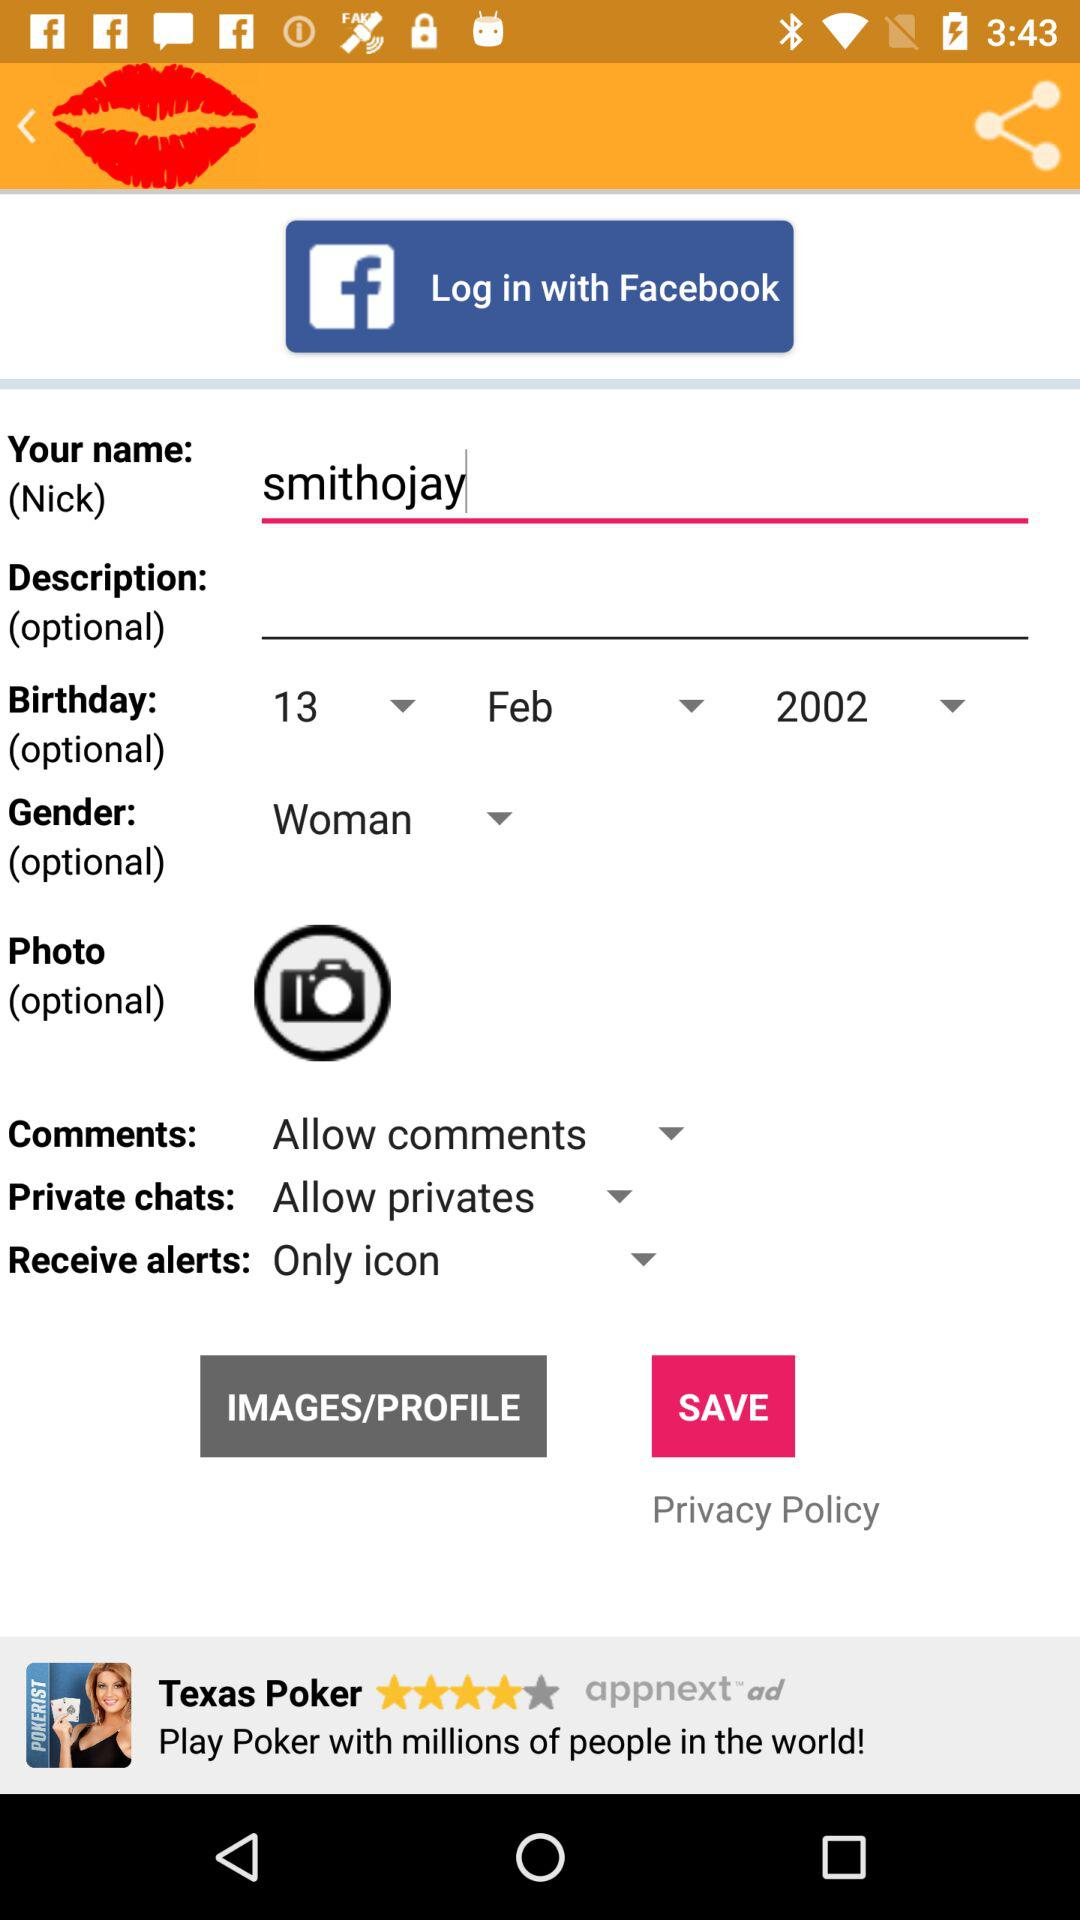What is the name of the person? The name of the person is Smithojay. 